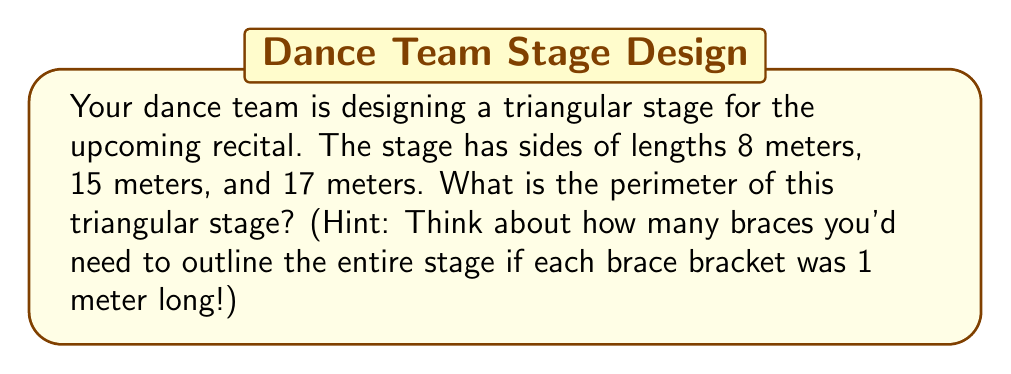What is the answer to this math problem? Let's approach this step-by-step:

1) The perimeter of a triangle is the sum of the lengths of all its sides.

2) We are given the following side lengths:
   Side 1: 8 meters
   Side 2: 15 meters
   Side 3: 17 meters

3) To find the perimeter, we simply add these lengths:

   $$ \text{Perimeter} = 8 \text{ m} + 15 \text{ m} + 17 \text{ m} $$

4) Performing the addition:

   $$ \text{Perimeter} = 40 \text{ meters} $$

5) Just like how braces outline your teeth, imagine each meter of the stage outline as a brace bracket. You'd need 40 of them to cover the entire perimeter!
Answer: 40 meters 